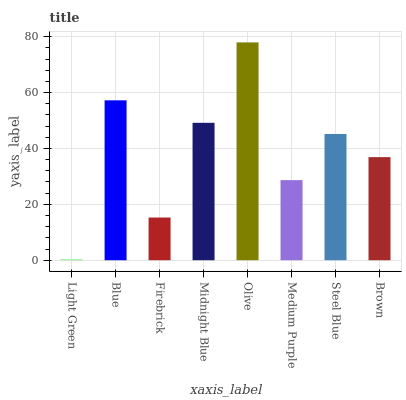Is Light Green the minimum?
Answer yes or no. Yes. Is Olive the maximum?
Answer yes or no. Yes. Is Blue the minimum?
Answer yes or no. No. Is Blue the maximum?
Answer yes or no. No. Is Blue greater than Light Green?
Answer yes or no. Yes. Is Light Green less than Blue?
Answer yes or no. Yes. Is Light Green greater than Blue?
Answer yes or no. No. Is Blue less than Light Green?
Answer yes or no. No. Is Steel Blue the high median?
Answer yes or no. Yes. Is Brown the low median?
Answer yes or no. Yes. Is Brown the high median?
Answer yes or no. No. Is Blue the low median?
Answer yes or no. No. 